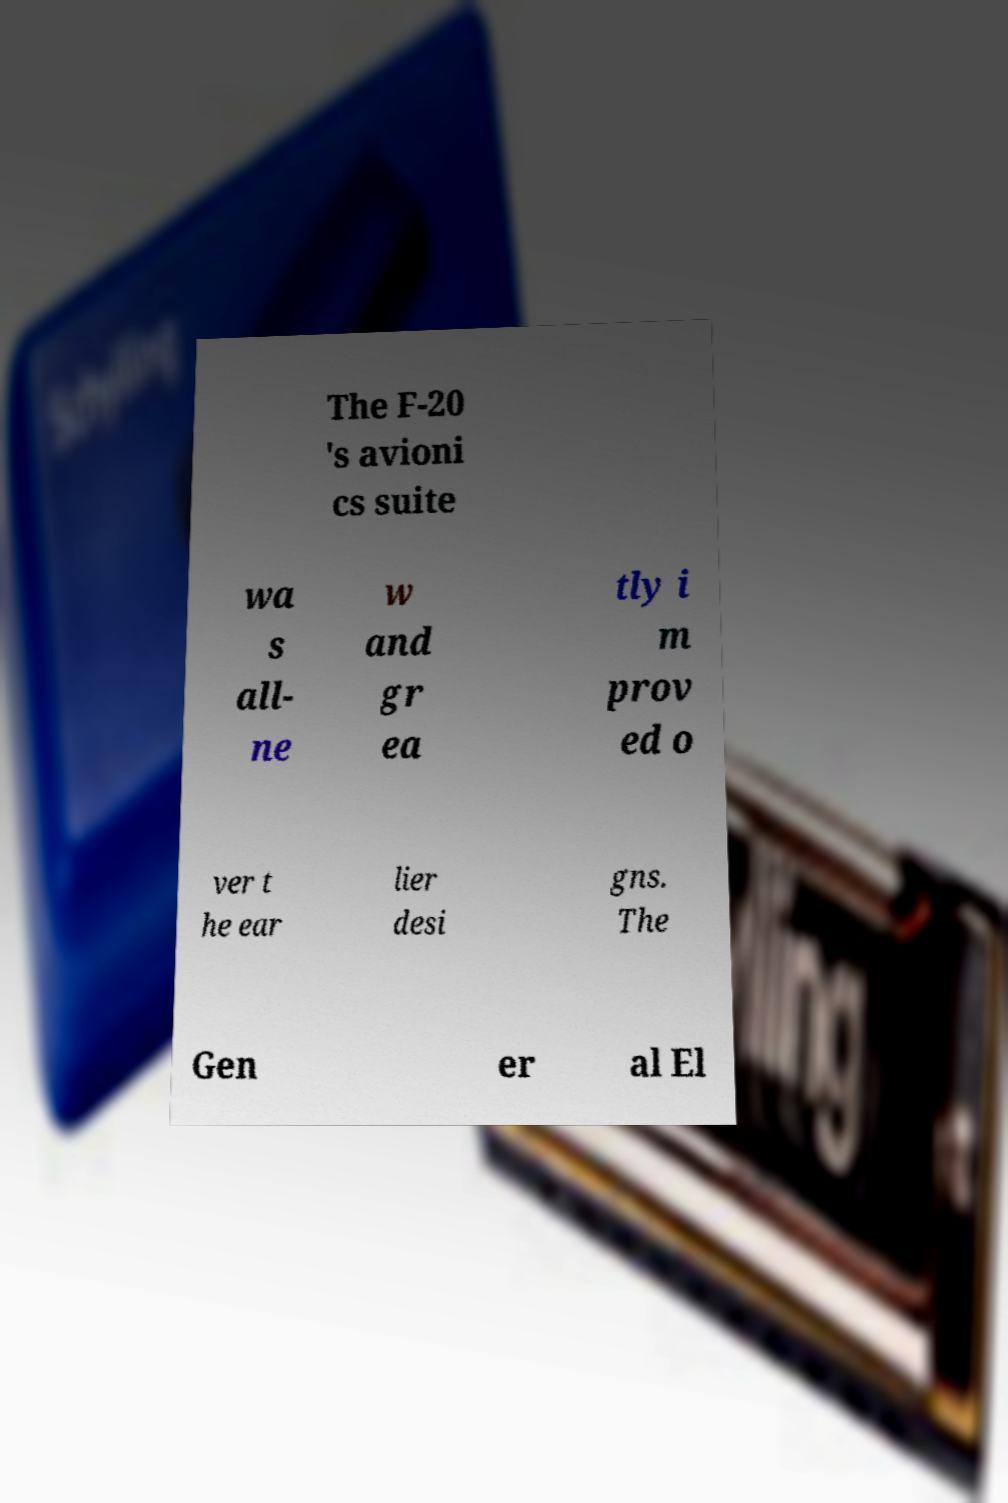What messages or text are displayed in this image? I need them in a readable, typed format. The F-20 's avioni cs suite wa s all- ne w and gr ea tly i m prov ed o ver t he ear lier desi gns. The Gen er al El 